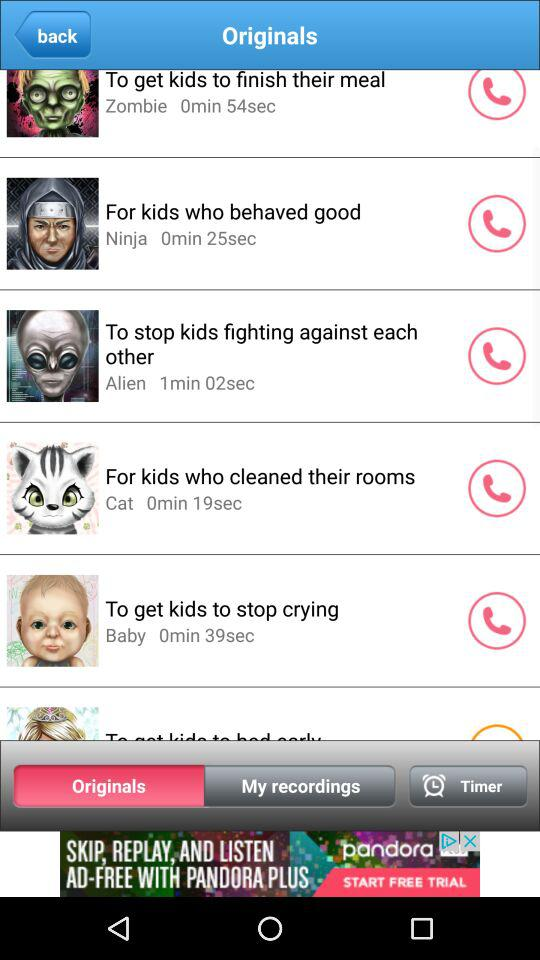What is the name of the alien ringtone?
When the provided information is insufficient, respond with <no answer>. <no answer> 